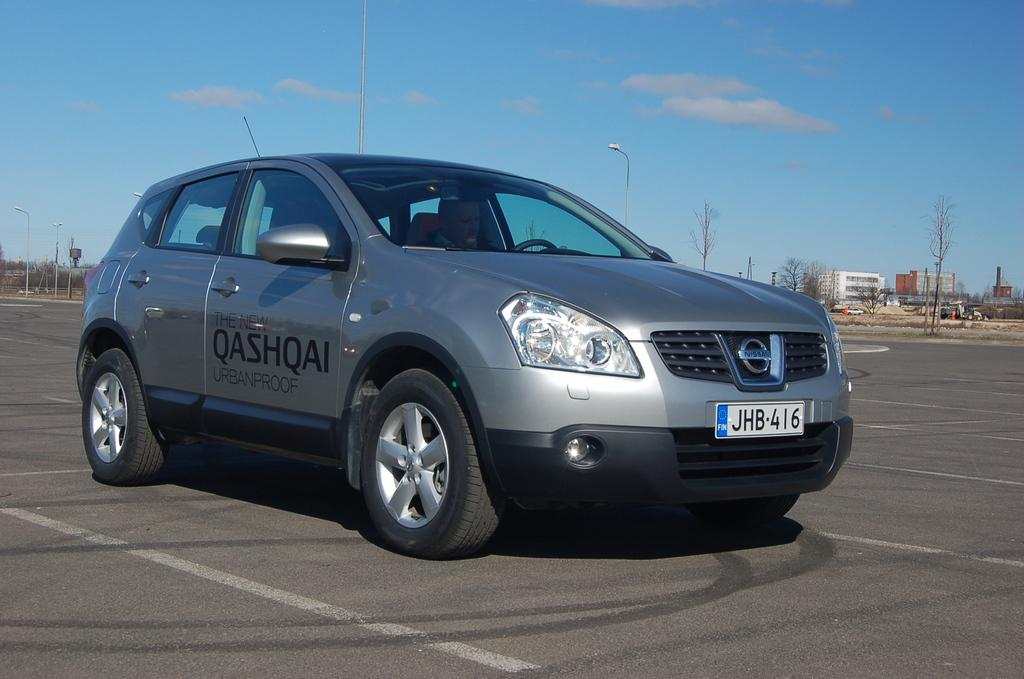What is the main subject of the image? There is a car in the image. Where is the car located? The car is on the road. What can be seen behind the car? There are trees and buildings behind the car. What type of club is the car using to drive in the image? There is no club present in the image; the car is driving on the road using its wheels. 